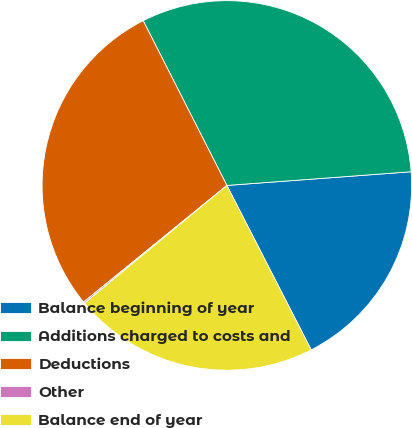Convert chart. <chart><loc_0><loc_0><loc_500><loc_500><pie_chart><fcel>Balance beginning of year<fcel>Additions charged to costs and<fcel>Deductions<fcel>Other<fcel>Balance end of year<nl><fcel>18.64%<fcel>31.3%<fcel>28.39%<fcel>0.13%<fcel>21.54%<nl></chart> 